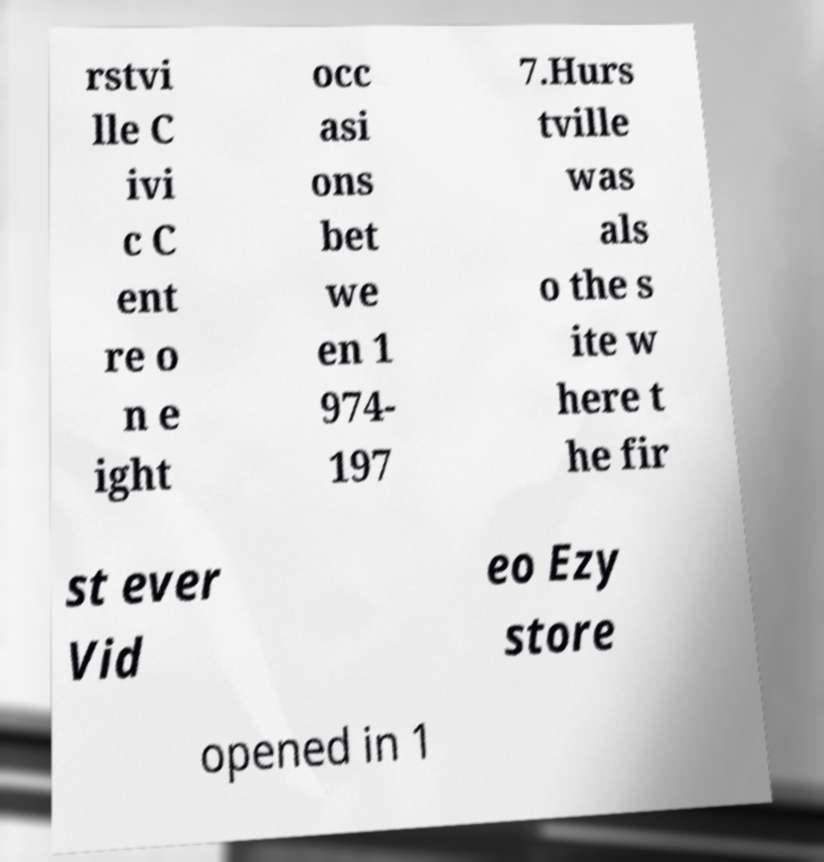I need the written content from this picture converted into text. Can you do that? rstvi lle C ivi c C ent re o n e ight occ asi ons bet we en 1 974- 197 7.Hurs tville was als o the s ite w here t he fir st ever Vid eo Ezy store opened in 1 